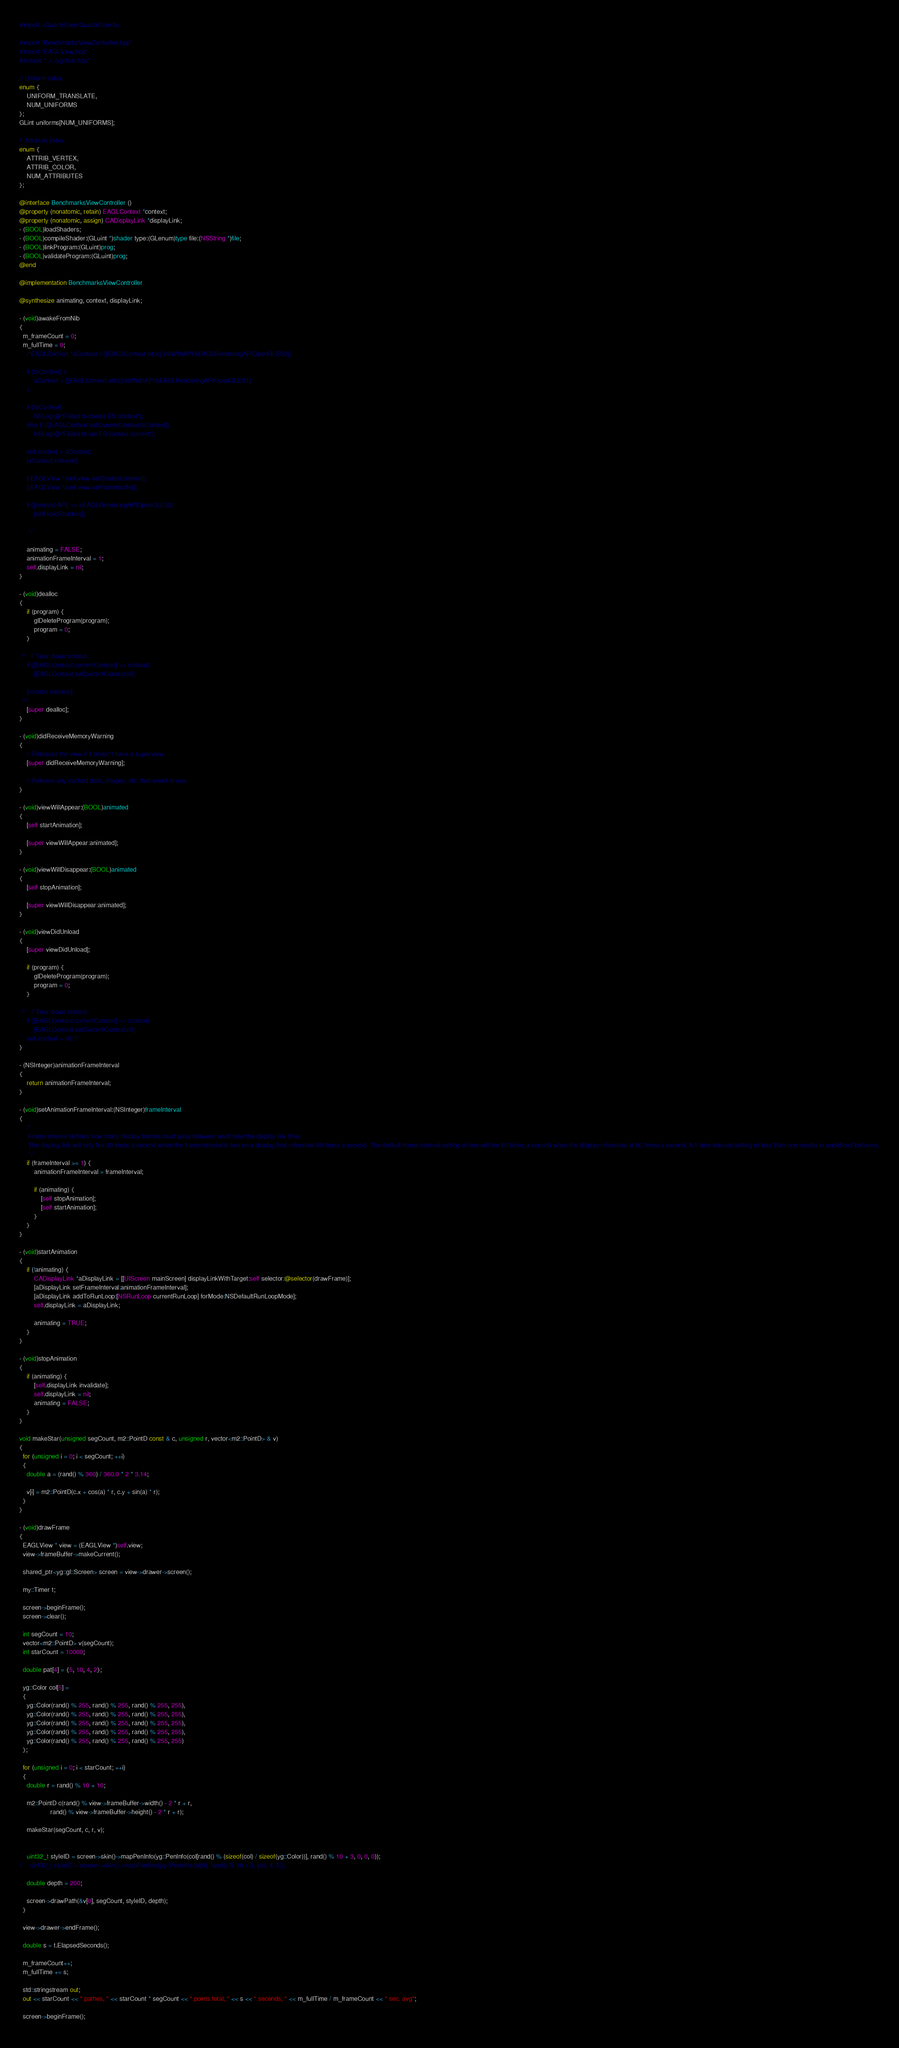Convert code to text. <code><loc_0><loc_0><loc_500><loc_500><_ObjectiveC_>#import <QuartzCore/QuartzCore.h>

#import "BenchmarksViewController.hpp"
#import "EAGLView.hpp"
#include "../../yg/skin.hpp"

// Uniform index.
enum {
    UNIFORM_TRANSLATE,
    NUM_UNIFORMS
};
GLint uniforms[NUM_UNIFORMS];

// Attribute index.
enum {
    ATTRIB_VERTEX,
    ATTRIB_COLOR,
    NUM_ATTRIBUTES
};

@interface BenchmarksViewController ()
@property (nonatomic, retain) EAGLContext *context;
@property (nonatomic, assign) CADisplayLink *displayLink;
- (BOOL)loadShaders;
- (BOOL)compileShader:(GLuint *)shader type:(GLenum)type file:(NSString *)file;
- (BOOL)linkProgram:(GLuint)prog;
- (BOOL)validateProgram:(GLuint)prog;
@end

@implementation BenchmarksViewController

@synthesize animating, context, displayLink;

- (void)awakeFromNib
{
  m_frameCount = 0;
  m_fullTime = 0;
    /*EAGLContext *aContext = [[EAGLContext alloc] initWithAPI:kEAGLRenderingAPIOpenGLES2];
    
    if (!aContext) {
        aContext = [[EAGLContext alloc] initWithAPI:kEAGLRenderingAPIOpenGLES1];
    }
    
    if (!aContext)
        NSLog(@"Failed to create ES context");
    else if (![EAGLContext setCurrentContext:aContext])
        NSLog(@"Failed to set ES context current");
    
	self.context = aContext;
	[aContext release];
	
    [(EAGLView *)self.view setContext:context];
    [(EAGLView *)self.view setFramebuffer];
    
    if ([context API] == kEAGLRenderingAPIOpenGLES2)
        [self loadShaders];
    
     */
     
    animating = FALSE;
    animationFrameInterval = 1;
    self.displayLink = nil;
}

- (void)dealloc
{
    if (program) {
        glDeleteProgram(program);
        program = 0;
    }
    
 /*   // Tear down context.
    if ([EAGLContext currentContext] == context)
        [EAGLContext setCurrentContext:nil];
    
    [context release];
  */   
    [super dealloc];
}

- (void)didReceiveMemoryWarning
{
    // Releases the view if it doesn't have a superview.
    [super didReceiveMemoryWarning];
    
    // Release any cached data, images, etc. that aren't in use.
}

- (void)viewWillAppear:(BOOL)animated
{
    [self startAnimation];
    
    [super viewWillAppear:animated];
}

- (void)viewWillDisappear:(BOOL)animated
{
    [self stopAnimation];
    
    [super viewWillDisappear:animated];
}

- (void)viewDidUnload
{
	[super viewDidUnload];
	
    if (program) {
        glDeleteProgram(program);
        program = 0;
    }

 /*   // Tear down context.
    if ([EAGLContext currentContext] == context)
        [EAGLContext setCurrentContext:nil];
	self.context = nil; */	
}

- (NSInteger)animationFrameInterval
{
    return animationFrameInterval;
}

- (void)setAnimationFrameInterval:(NSInteger)frameInterval
{
    /*
	 Frame interval defines how many display frames must pass between each time the display link fires.
	 The display link will only fire 30 times a second when the frame internal is two on a display that refreshes 60 times a second. The default frame interval setting of one will fire 60 times a second when the display refreshes at 60 times a second. A frame interval setting of less than one results in undefined behavior.
	 */
    if (frameInterval >= 1) {
        animationFrameInterval = frameInterval;
        
        if (animating) {
            [self stopAnimation];
            [self startAnimation];
        }
    }
}

- (void)startAnimation
{
    if (!animating) {
        CADisplayLink *aDisplayLink = [[UIScreen mainScreen] displayLinkWithTarget:self selector:@selector(drawFrame)];
        [aDisplayLink setFrameInterval:animationFrameInterval];
        [aDisplayLink addToRunLoop:[NSRunLoop currentRunLoop] forMode:NSDefaultRunLoopMode];
        self.displayLink = aDisplayLink;
        
        animating = TRUE;
    }
}

- (void)stopAnimation
{
    if (animating) {
        [self.displayLink invalidate];
        self.displayLink = nil;
        animating = FALSE;
    }
}

void makeStar(unsigned segCount, m2::PointD const & c, unsigned r, vector<m2::PointD> & v)
{
  for (unsigned i = 0; i < segCount; ++i)
  {
    double a = (rand() % 360) / 360.0 * 2 * 3.14;
    
    v[i] = m2::PointD(c.x + cos(a) * r, c.y + sin(a) * r);
  }
}

- (void)drawFrame
{
  EAGLView * view = (EAGLView *)self.view;
  view->frameBuffer->makeCurrent();

  shared_ptr<yg::gl::Screen> screen = view->drawer->screen();
  
  my::Timer t;
  
  screen->beginFrame();
  screen->clear();

  int segCount = 10;
  vector<m2::PointD> v(segCount);
  int starCount = 10000;
  
  double pat[4] = {5, 10, 4, 2};

  yg::Color col[5] = 
  {
    yg::Color(rand() % 255, rand() % 255, rand() % 255, 255),
    yg::Color(rand() % 255, rand() % 255, rand() % 255, 255),
    yg::Color(rand() % 255, rand() % 255, rand() % 255, 255),
    yg::Color(rand() % 255, rand() % 255, rand() % 255, 255),
    yg::Color(rand() % 255, rand() % 255, rand() % 255, 255)
  };
  
  for (unsigned i = 0; i < starCount; ++i)
  {
    double r = rand() % 10 + 10;
    
    m2::PointD c(rand() % view->frameBuffer->width() - 2 * r + r,
                 rand() % view->frameBuffer->height() - 2 * r + r);
    
    makeStar(segCount, c, r, v);
    
    
    uint32_t styleID = screen->skin()->mapPenInfo(yg::PenInfo(col[rand() % (sizeof(col) / sizeof(yg::Color))], rand() % 10 + 3, 0, 0, 0));
//    uint32_t styleID = screen->skin()->mapPenInfo(yg::PenInfo(col[0], rand() % 10 + 3, pat, 4, 0));
   
    double depth = 200;
    
    screen->drawPath(&v[0], segCount, styleID, depth);
  }
  
  view->drawer->endFrame();

  double s = t.ElapsedSeconds();
  
  m_frameCount++;
  m_fullTime += s;
  
  std::stringstream out;
  out << starCount << " pathes, " << starCount * segCount << " points total, " << s << " seconds, " << m_fullTime / m_frameCount << " sec. avg";
  
  screen->beginFrame();
  </code> 